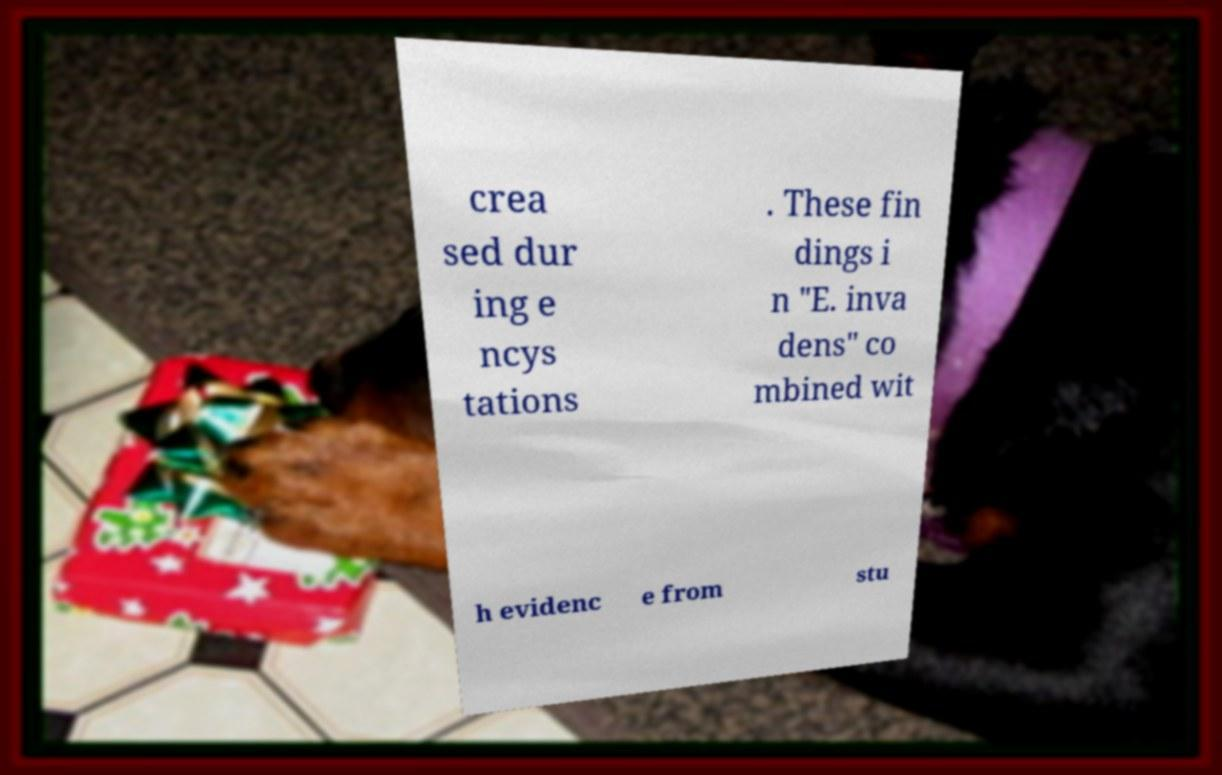Could you assist in decoding the text presented in this image and type it out clearly? crea sed dur ing e ncys tations . These fin dings i n "E. inva dens" co mbined wit h evidenc e from stu 